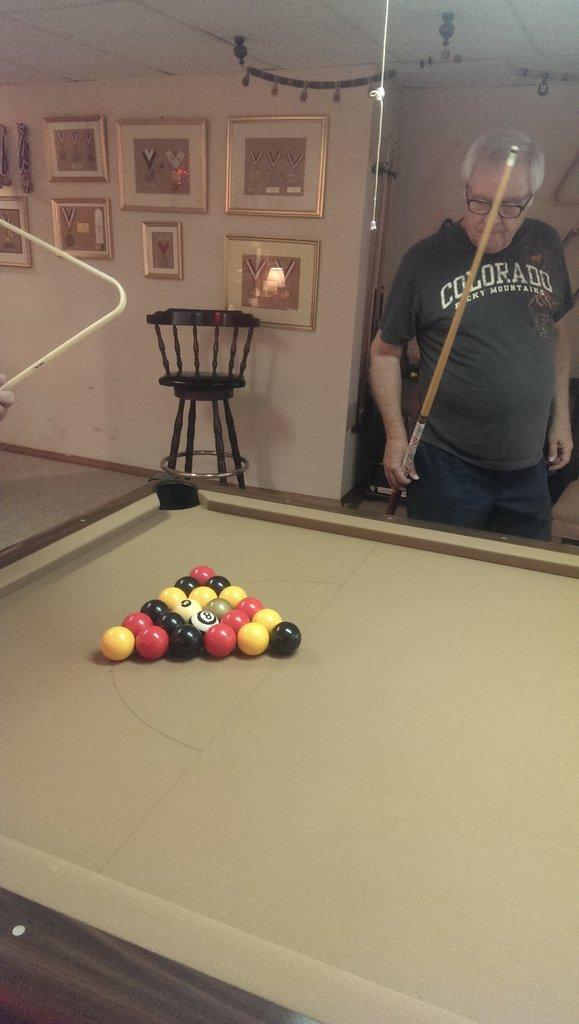What is the man holding in the image? The man is holding a stick. What game is being played in the image? There is a snookers board with balls in the image, suggesting that the game being played is snooker. What can be seen on the wall in the image? There are photo frames on the wall. What type of furniture is near the wall? There is a chair near the wall. What discovery was made during the game of snooker in the image? There is no indication of a discovery being made during the game of snooker in the image. 